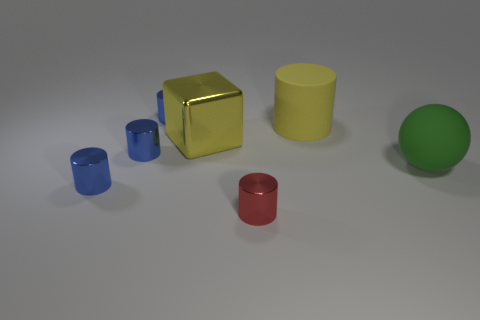Subtract all tiny red cylinders. How many cylinders are left? 4 Add 1 red shiny objects. How many objects exist? 8 Subtract all blue cylinders. How many cylinders are left? 2 Subtract 4 cylinders. How many cylinders are left? 1 Subtract all purple cylinders. Subtract all red spheres. How many cylinders are left? 5 Subtract all cyan cylinders. How many gray spheres are left? 0 Subtract all blue cylinders. Subtract all large green rubber things. How many objects are left? 3 Add 6 red metallic objects. How many red metallic objects are left? 7 Add 6 tiny blue blocks. How many tiny blue blocks exist? 6 Subtract 0 gray spheres. How many objects are left? 7 